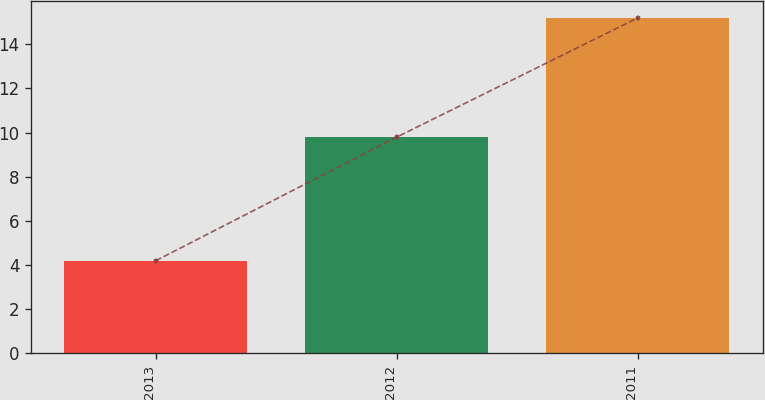<chart> <loc_0><loc_0><loc_500><loc_500><bar_chart><fcel>2013<fcel>2012<fcel>2011<nl><fcel>4.2<fcel>9.8<fcel>15.2<nl></chart> 